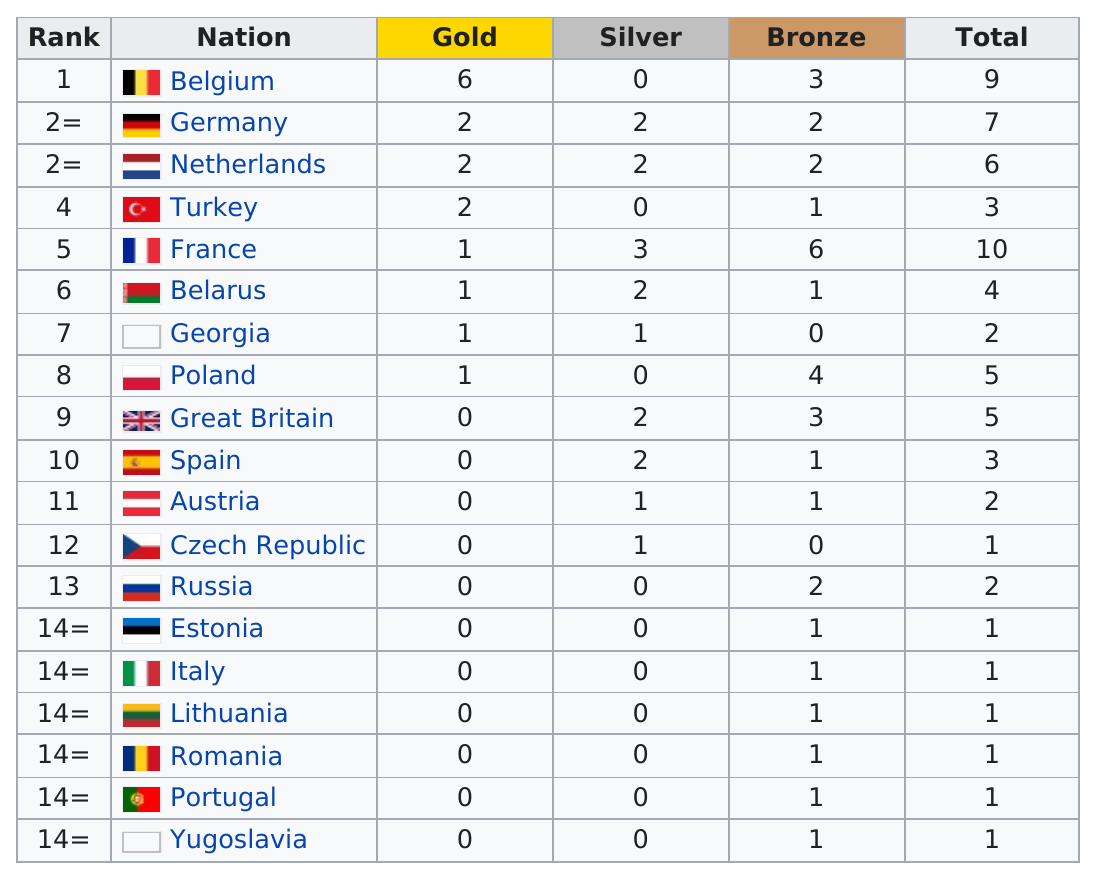Highlight a few significant elements in this photo. France has 4 more bronze medals than Russia. Belgium, France, and Turkey have a total of 9 gold medals. Germany won a total of 7 medals. As of my knowledge cutoff date of September 2021, Russia has a total of 2 non-gold medals in the Winter Olympics. I declare that Poland has obtained one gold medal. 